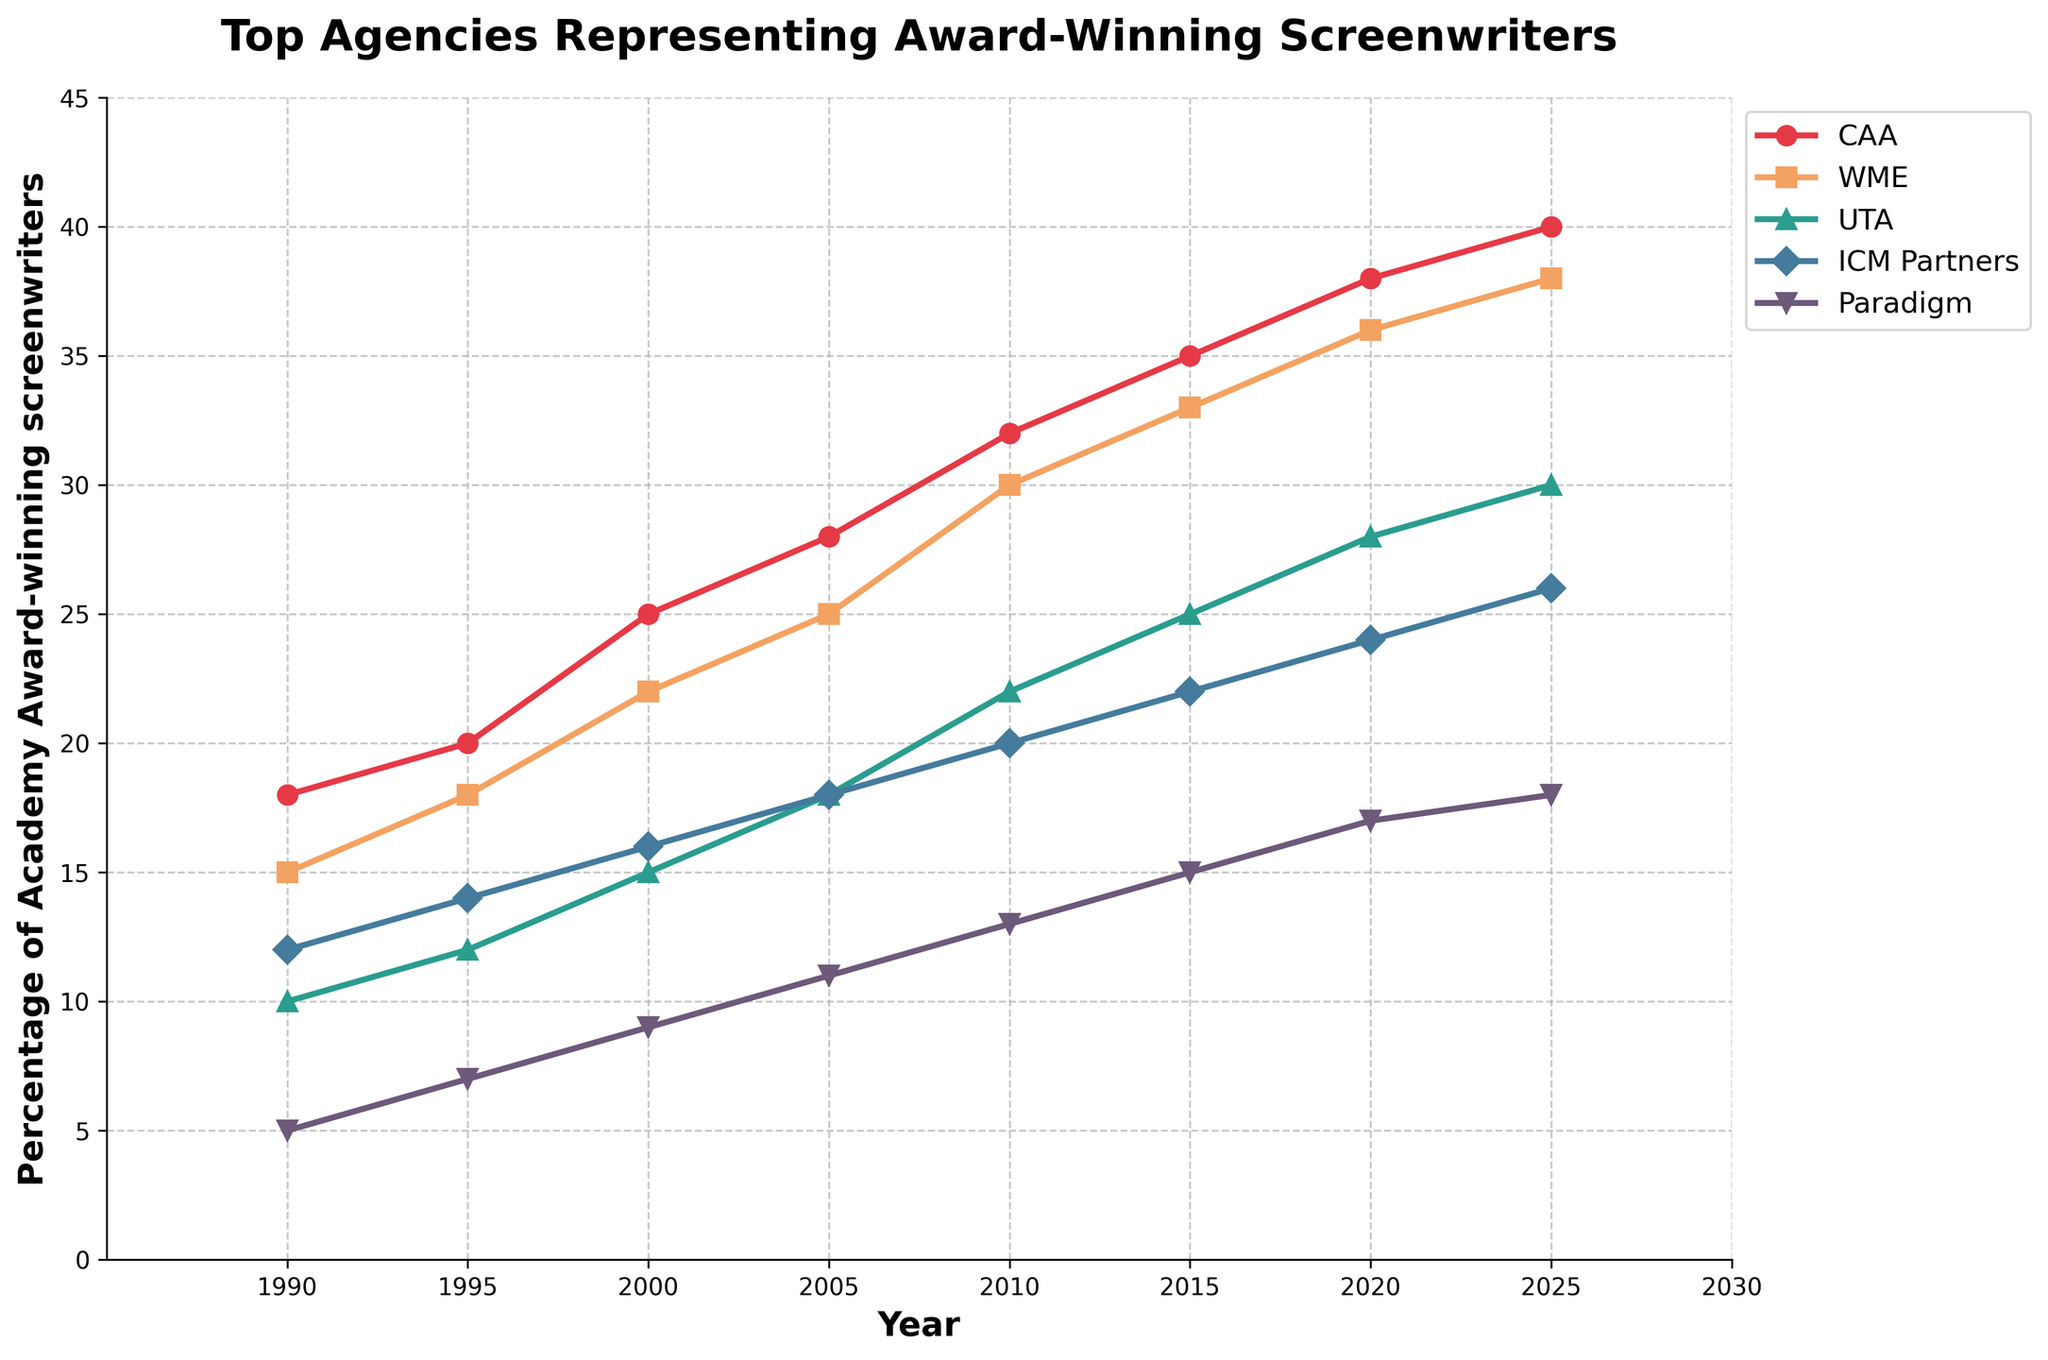What's the percentage increase of Academy Award-winning screenwriters represented by CAA from 1990 to 2025? To find the percentage increase, we use the formula: [(new value - old value) / old value] * 100. For CAA, the new value in 2025 is 40 and the old value in 1990 is 18. The calculation is [(40 - 18) / 18] * 100.
Answer: 122.22% Which agency had the greatest increase in percentage representation of Academy Award-winning screenwriters from 2000 to 2020? To determine the greatest increase, we calculate the difference in percentages from 2000 to 2020 for each agency. For CAA: 38 - 25 = 13, WME: 36 - 22 = 14, UTA: 28 - 15 = 13, ICM Partners: 24 - 16 = 8, Paradigm: 17 - 9 = 8. WME has the greatest increase with 14%.
Answer: WME In 2010, which agency represented the lowest percentage of Academy Award-winning screenwriters? By examining the chart for the year 2010, Paradigm has the lowest representation percentage, which is 13.
Answer: Paradigm Compare the percentage of Academy Award-winning screenwriters represented by WME and UTA in 2015. Which agency represented more, and by how much? In 2015, WME represented 33% and UTA represented 25%. The difference is 33 - 25 = 8. WME represented more by 8%.
Answer: WME by 8% In what year did ICM Partners and Paradigm have the same percentage representation, and what was the percentage? By examining the chart, in 1990, both ICM Partners and Paradigm represented 12% and 5% respectively. There is no year where their percentages are the same.
Answer: None What is the average percentage representation of Academy Award-winning screenwriters by UTA across all the years shown? The percentages for UTA from 1990 to 2025 are 10, 12, 15, 18, 22, 25, 28, 30. Summing these gives 160. The average is 160 / 8 = 20.
Answer: 20 Which agency had the least growth in the percentage representation of Academy Award-winning screenwriters from 1990 to 2025? To find the least growth, we calculate the difference in percentages from 1990 to 2025 for each agency. For CAA: 40 - 18 = 22, WME: 38 - 15 = 23, UTA: 30 - 10 = 20, ICM Partners: 26 - 12 = 14, Paradigm: 18 - 5 = 13. Paradigm had the least growth with 13%.
Answer: Paradigm What is the total percentage representation of Academy Award-winning screenwriters by all five agencies in 2025? Summing the percentages of all agencies in 2025; CAA: 40, WME: 38, UTA: 30, ICM Partners: 26, Paradigm: 18. The total is 40 + 38 + 30 + 26 + 18 = 152.
Answer: 152 